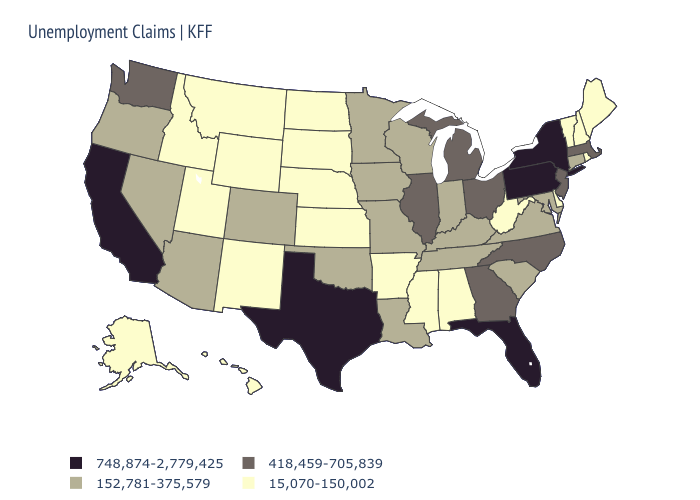What is the lowest value in states that border Mississippi?
Give a very brief answer. 15,070-150,002. Name the states that have a value in the range 15,070-150,002?
Keep it brief. Alabama, Alaska, Arkansas, Delaware, Hawaii, Idaho, Kansas, Maine, Mississippi, Montana, Nebraska, New Hampshire, New Mexico, North Dakota, Rhode Island, South Dakota, Utah, Vermont, West Virginia, Wyoming. What is the highest value in the USA?
Concise answer only. 748,874-2,779,425. What is the highest value in the USA?
Give a very brief answer. 748,874-2,779,425. Does Hawaii have the lowest value in the USA?
Short answer required. Yes. Name the states that have a value in the range 418,459-705,839?
Quick response, please. Georgia, Illinois, Massachusetts, Michigan, New Jersey, North Carolina, Ohio, Washington. What is the lowest value in states that border Michigan?
Concise answer only. 152,781-375,579. Name the states that have a value in the range 418,459-705,839?
Be succinct. Georgia, Illinois, Massachusetts, Michigan, New Jersey, North Carolina, Ohio, Washington. What is the value of Tennessee?
Quick response, please. 152,781-375,579. Does Nebraska have the lowest value in the USA?
Quick response, please. Yes. What is the lowest value in the USA?
Give a very brief answer. 15,070-150,002. Does the first symbol in the legend represent the smallest category?
Keep it brief. No. Does Pennsylvania have the highest value in the USA?
Keep it brief. Yes. Does California have the lowest value in the USA?
Write a very short answer. No. Among the states that border North Dakota , which have the lowest value?
Quick response, please. Montana, South Dakota. 